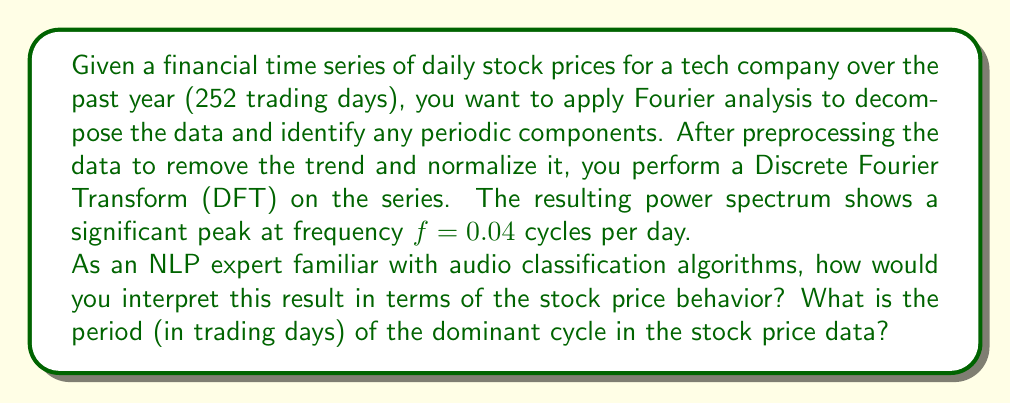What is the answer to this math problem? To interpret this result and calculate the period of the dominant cycle, we need to understand the relationship between frequency and period in Fourier analysis:

1) In Fourier analysis, frequency ($f$) and period ($T$) are inversely related:

   $$T = \frac{1}{f}$$

2) We are given that the significant peak occurs at $f = 0.04$ cycles per day.

3) To find the period, we simply need to apply the formula:

   $$T = \frac{1}{0.04} = 25$$

4) Interpretation:
   - The period of 25 trading days corresponds to approximately 5 weeks in calendar time (considering 5 trading days per week).
   - This suggests a monthly cycle in the stock price data, which could be related to various factors such as monthly economic reports, earnings announcements, or option expiration cycles.

5) From an NLP and audio classification perspective, this analysis is similar to identifying the fundamental frequency or dominant pitch in an audio signal. In audio processing, lower frequencies correspond to lower pitches and longer wavelengths, analogous to longer periods in financial time series.

6) Just as in speech recognition where identifying key frequencies can help distinguish between phonemes, in financial time series analysis, identifying key periodicities can help distinguish between different types of market behaviors or cycles.
Answer: The period of the dominant cycle in the stock price data is 25 trading days. 